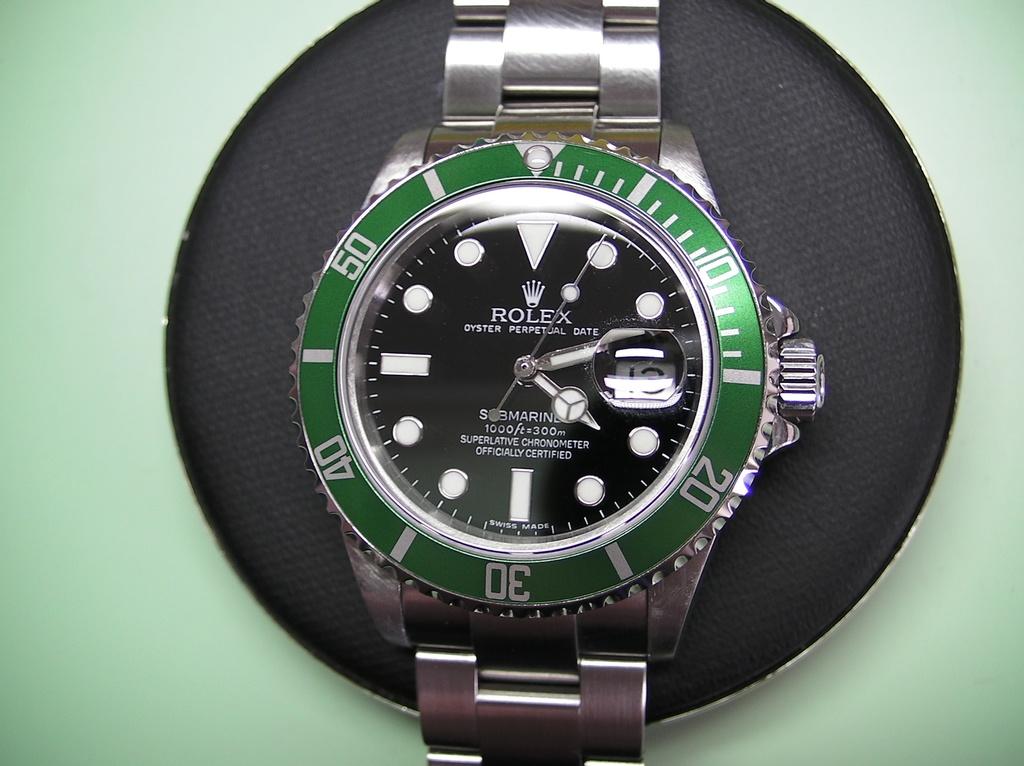What model of rolex is this?
Make the answer very short. Oyster perpetual date. What is the brand of watch?
Offer a very short reply. Rolex. 